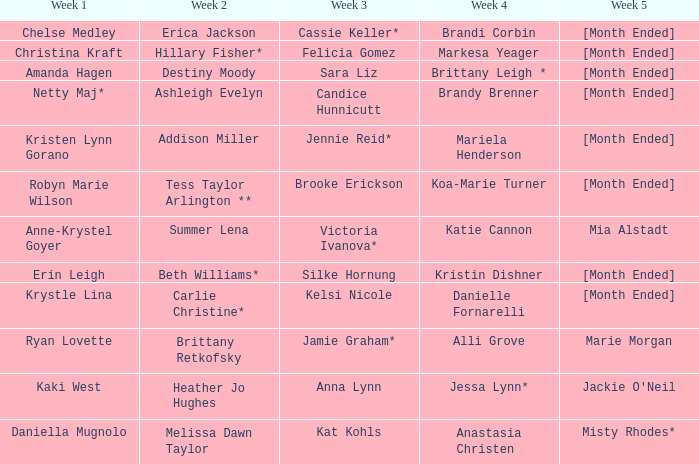What is the week 3 with addison miller in week 2? Jennie Reid*. Can you parse all the data within this table? {'header': ['Week 1', 'Week 2', 'Week 3', 'Week 4', 'Week 5'], 'rows': [['Chelse Medley', 'Erica Jackson', 'Cassie Keller*', 'Brandi Corbin', '[Month Ended]'], ['Christina Kraft', 'Hillary Fisher*', 'Felicia Gomez', 'Markesa Yeager', '[Month Ended]'], ['Amanda Hagen', 'Destiny Moody', 'Sara Liz', 'Brittany Leigh *', '[Month Ended]'], ['Netty Maj*', 'Ashleigh Evelyn', 'Candice Hunnicutt', 'Brandy Brenner', '[Month Ended]'], ['Kristen Lynn Gorano', 'Addison Miller', 'Jennie Reid*', 'Mariela Henderson', '[Month Ended]'], ['Robyn Marie Wilson', 'Tess Taylor Arlington **', 'Brooke Erickson', 'Koa-Marie Turner', '[Month Ended]'], ['Anne-Krystel Goyer', 'Summer Lena', 'Victoria Ivanova*', 'Katie Cannon', 'Mia Alstadt'], ['Erin Leigh', 'Beth Williams*', 'Silke Hornung', 'Kristin Dishner', '[Month Ended]'], ['Krystle Lina', 'Carlie Christine*', 'Kelsi Nicole', 'Danielle Fornarelli', '[Month Ended]'], ['Ryan Lovette', 'Brittany Retkofsky', 'Jamie Graham*', 'Alli Grove', 'Marie Morgan'], ['Kaki West', 'Heather Jo Hughes', 'Anna Lynn', 'Jessa Lynn*', "Jackie O'Neil"], ['Daniella Mugnolo', 'Melissa Dawn Taylor', 'Kat Kohls', 'Anastasia Christen', 'Misty Rhodes*']]} 